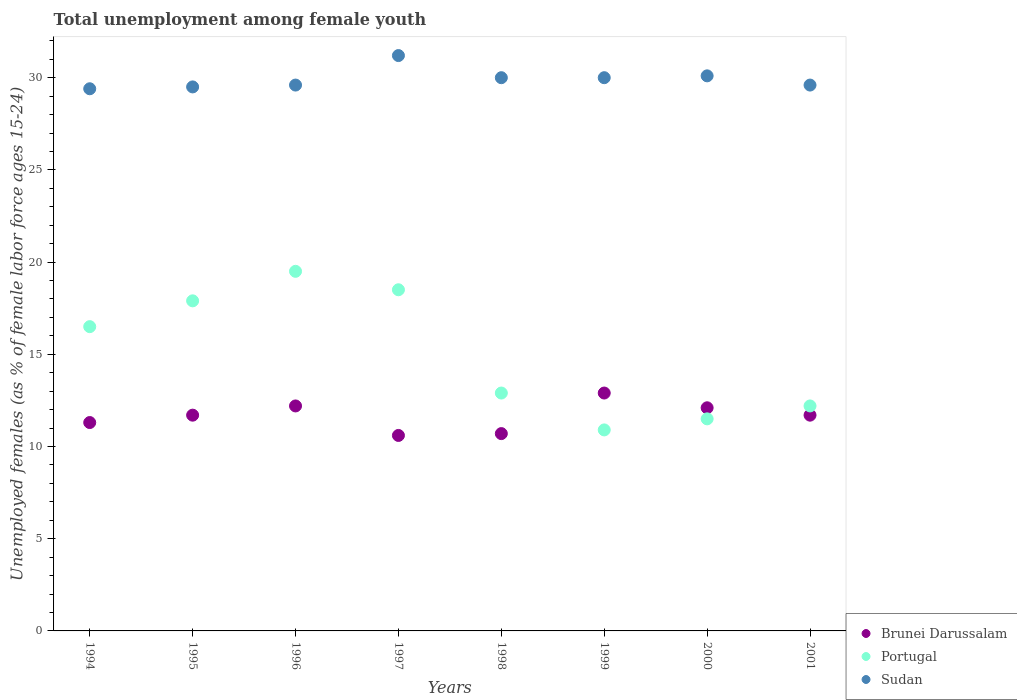Is the number of dotlines equal to the number of legend labels?
Offer a terse response. Yes. What is the percentage of unemployed females in in Sudan in 1999?
Provide a short and direct response. 30. Across all years, what is the maximum percentage of unemployed females in in Sudan?
Your answer should be compact. 31.2. Across all years, what is the minimum percentage of unemployed females in in Brunei Darussalam?
Your answer should be compact. 10.6. In which year was the percentage of unemployed females in in Sudan maximum?
Give a very brief answer. 1997. In which year was the percentage of unemployed females in in Portugal minimum?
Provide a succinct answer. 1999. What is the total percentage of unemployed females in in Portugal in the graph?
Give a very brief answer. 119.9. What is the difference between the percentage of unemployed females in in Sudan in 1996 and that in 1999?
Offer a very short reply. -0.4. What is the difference between the percentage of unemployed females in in Sudan in 1999 and the percentage of unemployed females in in Brunei Darussalam in 1996?
Offer a terse response. 17.8. What is the average percentage of unemployed females in in Portugal per year?
Offer a terse response. 14.99. In the year 1999, what is the difference between the percentage of unemployed females in in Sudan and percentage of unemployed females in in Portugal?
Your answer should be very brief. 19.1. In how many years, is the percentage of unemployed females in in Portugal greater than 24 %?
Provide a short and direct response. 0. What is the ratio of the percentage of unemployed females in in Portugal in 1997 to that in 2000?
Offer a terse response. 1.61. What is the difference between the highest and the second highest percentage of unemployed females in in Sudan?
Your answer should be very brief. 1.1. What is the difference between the highest and the lowest percentage of unemployed females in in Portugal?
Ensure brevity in your answer.  8.6. Is it the case that in every year, the sum of the percentage of unemployed females in in Sudan and percentage of unemployed females in in Brunei Darussalam  is greater than the percentage of unemployed females in in Portugal?
Give a very brief answer. Yes. How many years are there in the graph?
Give a very brief answer. 8. Are the values on the major ticks of Y-axis written in scientific E-notation?
Provide a succinct answer. No. Where does the legend appear in the graph?
Provide a short and direct response. Bottom right. What is the title of the graph?
Your answer should be compact. Total unemployment among female youth. Does "Thailand" appear as one of the legend labels in the graph?
Your response must be concise. No. What is the label or title of the X-axis?
Ensure brevity in your answer.  Years. What is the label or title of the Y-axis?
Offer a terse response. Unemployed females (as % of female labor force ages 15-24). What is the Unemployed females (as % of female labor force ages 15-24) of Brunei Darussalam in 1994?
Provide a succinct answer. 11.3. What is the Unemployed females (as % of female labor force ages 15-24) of Sudan in 1994?
Make the answer very short. 29.4. What is the Unemployed females (as % of female labor force ages 15-24) in Brunei Darussalam in 1995?
Give a very brief answer. 11.7. What is the Unemployed females (as % of female labor force ages 15-24) of Portugal in 1995?
Your answer should be very brief. 17.9. What is the Unemployed females (as % of female labor force ages 15-24) in Sudan in 1995?
Ensure brevity in your answer.  29.5. What is the Unemployed females (as % of female labor force ages 15-24) of Brunei Darussalam in 1996?
Keep it short and to the point. 12.2. What is the Unemployed females (as % of female labor force ages 15-24) of Portugal in 1996?
Give a very brief answer. 19.5. What is the Unemployed females (as % of female labor force ages 15-24) in Sudan in 1996?
Offer a terse response. 29.6. What is the Unemployed females (as % of female labor force ages 15-24) in Brunei Darussalam in 1997?
Your response must be concise. 10.6. What is the Unemployed females (as % of female labor force ages 15-24) in Sudan in 1997?
Keep it short and to the point. 31.2. What is the Unemployed females (as % of female labor force ages 15-24) in Brunei Darussalam in 1998?
Your answer should be compact. 10.7. What is the Unemployed females (as % of female labor force ages 15-24) in Portugal in 1998?
Make the answer very short. 12.9. What is the Unemployed females (as % of female labor force ages 15-24) of Sudan in 1998?
Make the answer very short. 30. What is the Unemployed females (as % of female labor force ages 15-24) in Brunei Darussalam in 1999?
Make the answer very short. 12.9. What is the Unemployed females (as % of female labor force ages 15-24) in Portugal in 1999?
Keep it short and to the point. 10.9. What is the Unemployed females (as % of female labor force ages 15-24) of Sudan in 1999?
Your answer should be very brief. 30. What is the Unemployed females (as % of female labor force ages 15-24) of Brunei Darussalam in 2000?
Your answer should be compact. 12.1. What is the Unemployed females (as % of female labor force ages 15-24) in Portugal in 2000?
Offer a terse response. 11.5. What is the Unemployed females (as % of female labor force ages 15-24) of Sudan in 2000?
Make the answer very short. 30.1. What is the Unemployed females (as % of female labor force ages 15-24) of Brunei Darussalam in 2001?
Ensure brevity in your answer.  11.7. What is the Unemployed females (as % of female labor force ages 15-24) of Portugal in 2001?
Make the answer very short. 12.2. What is the Unemployed females (as % of female labor force ages 15-24) in Sudan in 2001?
Provide a short and direct response. 29.6. Across all years, what is the maximum Unemployed females (as % of female labor force ages 15-24) in Brunei Darussalam?
Offer a terse response. 12.9. Across all years, what is the maximum Unemployed females (as % of female labor force ages 15-24) of Portugal?
Offer a very short reply. 19.5. Across all years, what is the maximum Unemployed females (as % of female labor force ages 15-24) of Sudan?
Your answer should be very brief. 31.2. Across all years, what is the minimum Unemployed females (as % of female labor force ages 15-24) in Brunei Darussalam?
Your answer should be compact. 10.6. Across all years, what is the minimum Unemployed females (as % of female labor force ages 15-24) in Portugal?
Ensure brevity in your answer.  10.9. Across all years, what is the minimum Unemployed females (as % of female labor force ages 15-24) of Sudan?
Your response must be concise. 29.4. What is the total Unemployed females (as % of female labor force ages 15-24) of Brunei Darussalam in the graph?
Offer a terse response. 93.2. What is the total Unemployed females (as % of female labor force ages 15-24) in Portugal in the graph?
Your answer should be very brief. 119.9. What is the total Unemployed females (as % of female labor force ages 15-24) of Sudan in the graph?
Ensure brevity in your answer.  239.4. What is the difference between the Unemployed females (as % of female labor force ages 15-24) of Sudan in 1994 and that in 1995?
Make the answer very short. -0.1. What is the difference between the Unemployed females (as % of female labor force ages 15-24) of Sudan in 1994 and that in 1996?
Provide a succinct answer. -0.2. What is the difference between the Unemployed females (as % of female labor force ages 15-24) of Sudan in 1994 and that in 1997?
Provide a succinct answer. -1.8. What is the difference between the Unemployed females (as % of female labor force ages 15-24) of Brunei Darussalam in 1994 and that in 1999?
Ensure brevity in your answer.  -1.6. What is the difference between the Unemployed females (as % of female labor force ages 15-24) of Brunei Darussalam in 1994 and that in 2000?
Ensure brevity in your answer.  -0.8. What is the difference between the Unemployed females (as % of female labor force ages 15-24) of Portugal in 1994 and that in 2000?
Offer a terse response. 5. What is the difference between the Unemployed females (as % of female labor force ages 15-24) of Sudan in 1994 and that in 2000?
Make the answer very short. -0.7. What is the difference between the Unemployed females (as % of female labor force ages 15-24) of Portugal in 1994 and that in 2001?
Offer a very short reply. 4.3. What is the difference between the Unemployed females (as % of female labor force ages 15-24) of Brunei Darussalam in 1995 and that in 1996?
Your answer should be very brief. -0.5. What is the difference between the Unemployed females (as % of female labor force ages 15-24) of Portugal in 1995 and that in 1997?
Give a very brief answer. -0.6. What is the difference between the Unemployed females (as % of female labor force ages 15-24) in Sudan in 1995 and that in 1997?
Your response must be concise. -1.7. What is the difference between the Unemployed females (as % of female labor force ages 15-24) in Brunei Darussalam in 1995 and that in 1998?
Offer a terse response. 1. What is the difference between the Unemployed females (as % of female labor force ages 15-24) of Portugal in 1995 and that in 1998?
Keep it short and to the point. 5. What is the difference between the Unemployed females (as % of female labor force ages 15-24) in Portugal in 1995 and that in 1999?
Provide a succinct answer. 7. What is the difference between the Unemployed females (as % of female labor force ages 15-24) of Portugal in 1995 and that in 2000?
Your answer should be compact. 6.4. What is the difference between the Unemployed females (as % of female labor force ages 15-24) in Sudan in 1995 and that in 2000?
Offer a terse response. -0.6. What is the difference between the Unemployed females (as % of female labor force ages 15-24) in Brunei Darussalam in 1995 and that in 2001?
Give a very brief answer. 0. What is the difference between the Unemployed females (as % of female labor force ages 15-24) of Portugal in 1995 and that in 2001?
Your answer should be compact. 5.7. What is the difference between the Unemployed females (as % of female labor force ages 15-24) of Sudan in 1995 and that in 2001?
Keep it short and to the point. -0.1. What is the difference between the Unemployed females (as % of female labor force ages 15-24) in Portugal in 1996 and that in 1997?
Offer a very short reply. 1. What is the difference between the Unemployed females (as % of female labor force ages 15-24) of Brunei Darussalam in 1996 and that in 1998?
Your response must be concise. 1.5. What is the difference between the Unemployed females (as % of female labor force ages 15-24) in Brunei Darussalam in 1996 and that in 1999?
Your answer should be compact. -0.7. What is the difference between the Unemployed females (as % of female labor force ages 15-24) of Portugal in 1996 and that in 1999?
Make the answer very short. 8.6. What is the difference between the Unemployed females (as % of female labor force ages 15-24) in Sudan in 1996 and that in 1999?
Give a very brief answer. -0.4. What is the difference between the Unemployed females (as % of female labor force ages 15-24) of Sudan in 1996 and that in 2000?
Your answer should be compact. -0.5. What is the difference between the Unemployed females (as % of female labor force ages 15-24) in Portugal in 1996 and that in 2001?
Provide a short and direct response. 7.3. What is the difference between the Unemployed females (as % of female labor force ages 15-24) in Sudan in 1997 and that in 1999?
Provide a short and direct response. 1.2. What is the difference between the Unemployed females (as % of female labor force ages 15-24) in Portugal in 1997 and that in 2000?
Your answer should be compact. 7. What is the difference between the Unemployed females (as % of female labor force ages 15-24) of Sudan in 1997 and that in 2001?
Your answer should be very brief. 1.6. What is the difference between the Unemployed females (as % of female labor force ages 15-24) of Sudan in 1998 and that in 2001?
Keep it short and to the point. 0.4. What is the difference between the Unemployed females (as % of female labor force ages 15-24) of Portugal in 1999 and that in 2000?
Offer a terse response. -0.6. What is the difference between the Unemployed females (as % of female labor force ages 15-24) of Portugal in 1999 and that in 2001?
Provide a succinct answer. -1.3. What is the difference between the Unemployed females (as % of female labor force ages 15-24) of Sudan in 2000 and that in 2001?
Make the answer very short. 0.5. What is the difference between the Unemployed females (as % of female labor force ages 15-24) of Brunei Darussalam in 1994 and the Unemployed females (as % of female labor force ages 15-24) of Portugal in 1995?
Provide a succinct answer. -6.6. What is the difference between the Unemployed females (as % of female labor force ages 15-24) in Brunei Darussalam in 1994 and the Unemployed females (as % of female labor force ages 15-24) in Sudan in 1995?
Provide a succinct answer. -18.2. What is the difference between the Unemployed females (as % of female labor force ages 15-24) in Brunei Darussalam in 1994 and the Unemployed females (as % of female labor force ages 15-24) in Sudan in 1996?
Offer a terse response. -18.3. What is the difference between the Unemployed females (as % of female labor force ages 15-24) of Brunei Darussalam in 1994 and the Unemployed females (as % of female labor force ages 15-24) of Sudan in 1997?
Your answer should be very brief. -19.9. What is the difference between the Unemployed females (as % of female labor force ages 15-24) of Portugal in 1994 and the Unemployed females (as % of female labor force ages 15-24) of Sudan in 1997?
Your response must be concise. -14.7. What is the difference between the Unemployed females (as % of female labor force ages 15-24) in Brunei Darussalam in 1994 and the Unemployed females (as % of female labor force ages 15-24) in Sudan in 1998?
Provide a succinct answer. -18.7. What is the difference between the Unemployed females (as % of female labor force ages 15-24) in Brunei Darussalam in 1994 and the Unemployed females (as % of female labor force ages 15-24) in Sudan in 1999?
Make the answer very short. -18.7. What is the difference between the Unemployed females (as % of female labor force ages 15-24) of Brunei Darussalam in 1994 and the Unemployed females (as % of female labor force ages 15-24) of Sudan in 2000?
Ensure brevity in your answer.  -18.8. What is the difference between the Unemployed females (as % of female labor force ages 15-24) of Portugal in 1994 and the Unemployed females (as % of female labor force ages 15-24) of Sudan in 2000?
Provide a succinct answer. -13.6. What is the difference between the Unemployed females (as % of female labor force ages 15-24) of Brunei Darussalam in 1994 and the Unemployed females (as % of female labor force ages 15-24) of Portugal in 2001?
Make the answer very short. -0.9. What is the difference between the Unemployed females (as % of female labor force ages 15-24) in Brunei Darussalam in 1994 and the Unemployed females (as % of female labor force ages 15-24) in Sudan in 2001?
Provide a short and direct response. -18.3. What is the difference between the Unemployed females (as % of female labor force ages 15-24) of Brunei Darussalam in 1995 and the Unemployed females (as % of female labor force ages 15-24) of Portugal in 1996?
Give a very brief answer. -7.8. What is the difference between the Unemployed females (as % of female labor force ages 15-24) in Brunei Darussalam in 1995 and the Unemployed females (as % of female labor force ages 15-24) in Sudan in 1996?
Give a very brief answer. -17.9. What is the difference between the Unemployed females (as % of female labor force ages 15-24) in Portugal in 1995 and the Unemployed females (as % of female labor force ages 15-24) in Sudan in 1996?
Your answer should be compact. -11.7. What is the difference between the Unemployed females (as % of female labor force ages 15-24) of Brunei Darussalam in 1995 and the Unemployed females (as % of female labor force ages 15-24) of Portugal in 1997?
Give a very brief answer. -6.8. What is the difference between the Unemployed females (as % of female labor force ages 15-24) in Brunei Darussalam in 1995 and the Unemployed females (as % of female labor force ages 15-24) in Sudan in 1997?
Keep it short and to the point. -19.5. What is the difference between the Unemployed females (as % of female labor force ages 15-24) of Brunei Darussalam in 1995 and the Unemployed females (as % of female labor force ages 15-24) of Portugal in 1998?
Give a very brief answer. -1.2. What is the difference between the Unemployed females (as % of female labor force ages 15-24) of Brunei Darussalam in 1995 and the Unemployed females (as % of female labor force ages 15-24) of Sudan in 1998?
Your answer should be compact. -18.3. What is the difference between the Unemployed females (as % of female labor force ages 15-24) in Portugal in 1995 and the Unemployed females (as % of female labor force ages 15-24) in Sudan in 1998?
Keep it short and to the point. -12.1. What is the difference between the Unemployed females (as % of female labor force ages 15-24) in Brunei Darussalam in 1995 and the Unemployed females (as % of female labor force ages 15-24) in Portugal in 1999?
Provide a succinct answer. 0.8. What is the difference between the Unemployed females (as % of female labor force ages 15-24) in Brunei Darussalam in 1995 and the Unemployed females (as % of female labor force ages 15-24) in Sudan in 1999?
Keep it short and to the point. -18.3. What is the difference between the Unemployed females (as % of female labor force ages 15-24) of Brunei Darussalam in 1995 and the Unemployed females (as % of female labor force ages 15-24) of Portugal in 2000?
Your answer should be compact. 0.2. What is the difference between the Unemployed females (as % of female labor force ages 15-24) of Brunei Darussalam in 1995 and the Unemployed females (as % of female labor force ages 15-24) of Sudan in 2000?
Your response must be concise. -18.4. What is the difference between the Unemployed females (as % of female labor force ages 15-24) in Brunei Darussalam in 1995 and the Unemployed females (as % of female labor force ages 15-24) in Sudan in 2001?
Provide a short and direct response. -17.9. What is the difference between the Unemployed females (as % of female labor force ages 15-24) in Brunei Darussalam in 1996 and the Unemployed females (as % of female labor force ages 15-24) in Sudan in 1998?
Ensure brevity in your answer.  -17.8. What is the difference between the Unemployed females (as % of female labor force ages 15-24) in Brunei Darussalam in 1996 and the Unemployed females (as % of female labor force ages 15-24) in Portugal in 1999?
Keep it short and to the point. 1.3. What is the difference between the Unemployed females (as % of female labor force ages 15-24) in Brunei Darussalam in 1996 and the Unemployed females (as % of female labor force ages 15-24) in Sudan in 1999?
Ensure brevity in your answer.  -17.8. What is the difference between the Unemployed females (as % of female labor force ages 15-24) of Portugal in 1996 and the Unemployed females (as % of female labor force ages 15-24) of Sudan in 1999?
Offer a terse response. -10.5. What is the difference between the Unemployed females (as % of female labor force ages 15-24) of Brunei Darussalam in 1996 and the Unemployed females (as % of female labor force ages 15-24) of Sudan in 2000?
Your answer should be very brief. -17.9. What is the difference between the Unemployed females (as % of female labor force ages 15-24) in Brunei Darussalam in 1996 and the Unemployed females (as % of female labor force ages 15-24) in Sudan in 2001?
Keep it short and to the point. -17.4. What is the difference between the Unemployed females (as % of female labor force ages 15-24) in Portugal in 1996 and the Unemployed females (as % of female labor force ages 15-24) in Sudan in 2001?
Your response must be concise. -10.1. What is the difference between the Unemployed females (as % of female labor force ages 15-24) of Brunei Darussalam in 1997 and the Unemployed females (as % of female labor force ages 15-24) of Sudan in 1998?
Make the answer very short. -19.4. What is the difference between the Unemployed females (as % of female labor force ages 15-24) of Portugal in 1997 and the Unemployed females (as % of female labor force ages 15-24) of Sudan in 1998?
Provide a succinct answer. -11.5. What is the difference between the Unemployed females (as % of female labor force ages 15-24) of Brunei Darussalam in 1997 and the Unemployed females (as % of female labor force ages 15-24) of Sudan in 1999?
Give a very brief answer. -19.4. What is the difference between the Unemployed females (as % of female labor force ages 15-24) of Portugal in 1997 and the Unemployed females (as % of female labor force ages 15-24) of Sudan in 1999?
Your response must be concise. -11.5. What is the difference between the Unemployed females (as % of female labor force ages 15-24) of Brunei Darussalam in 1997 and the Unemployed females (as % of female labor force ages 15-24) of Sudan in 2000?
Offer a terse response. -19.5. What is the difference between the Unemployed females (as % of female labor force ages 15-24) of Brunei Darussalam in 1997 and the Unemployed females (as % of female labor force ages 15-24) of Portugal in 2001?
Ensure brevity in your answer.  -1.6. What is the difference between the Unemployed females (as % of female labor force ages 15-24) in Portugal in 1997 and the Unemployed females (as % of female labor force ages 15-24) in Sudan in 2001?
Your response must be concise. -11.1. What is the difference between the Unemployed females (as % of female labor force ages 15-24) of Brunei Darussalam in 1998 and the Unemployed females (as % of female labor force ages 15-24) of Sudan in 1999?
Keep it short and to the point. -19.3. What is the difference between the Unemployed females (as % of female labor force ages 15-24) in Portugal in 1998 and the Unemployed females (as % of female labor force ages 15-24) in Sudan in 1999?
Ensure brevity in your answer.  -17.1. What is the difference between the Unemployed females (as % of female labor force ages 15-24) in Brunei Darussalam in 1998 and the Unemployed females (as % of female labor force ages 15-24) in Portugal in 2000?
Your response must be concise. -0.8. What is the difference between the Unemployed females (as % of female labor force ages 15-24) in Brunei Darussalam in 1998 and the Unemployed females (as % of female labor force ages 15-24) in Sudan in 2000?
Keep it short and to the point. -19.4. What is the difference between the Unemployed females (as % of female labor force ages 15-24) in Portugal in 1998 and the Unemployed females (as % of female labor force ages 15-24) in Sudan in 2000?
Keep it short and to the point. -17.2. What is the difference between the Unemployed females (as % of female labor force ages 15-24) of Brunei Darussalam in 1998 and the Unemployed females (as % of female labor force ages 15-24) of Sudan in 2001?
Keep it short and to the point. -18.9. What is the difference between the Unemployed females (as % of female labor force ages 15-24) of Portugal in 1998 and the Unemployed females (as % of female labor force ages 15-24) of Sudan in 2001?
Provide a short and direct response. -16.7. What is the difference between the Unemployed females (as % of female labor force ages 15-24) of Brunei Darussalam in 1999 and the Unemployed females (as % of female labor force ages 15-24) of Sudan in 2000?
Provide a succinct answer. -17.2. What is the difference between the Unemployed females (as % of female labor force ages 15-24) in Portugal in 1999 and the Unemployed females (as % of female labor force ages 15-24) in Sudan in 2000?
Offer a very short reply. -19.2. What is the difference between the Unemployed females (as % of female labor force ages 15-24) in Brunei Darussalam in 1999 and the Unemployed females (as % of female labor force ages 15-24) in Portugal in 2001?
Make the answer very short. 0.7. What is the difference between the Unemployed females (as % of female labor force ages 15-24) in Brunei Darussalam in 1999 and the Unemployed females (as % of female labor force ages 15-24) in Sudan in 2001?
Ensure brevity in your answer.  -16.7. What is the difference between the Unemployed females (as % of female labor force ages 15-24) of Portugal in 1999 and the Unemployed females (as % of female labor force ages 15-24) of Sudan in 2001?
Give a very brief answer. -18.7. What is the difference between the Unemployed females (as % of female labor force ages 15-24) of Brunei Darussalam in 2000 and the Unemployed females (as % of female labor force ages 15-24) of Portugal in 2001?
Provide a succinct answer. -0.1. What is the difference between the Unemployed females (as % of female labor force ages 15-24) of Brunei Darussalam in 2000 and the Unemployed females (as % of female labor force ages 15-24) of Sudan in 2001?
Offer a very short reply. -17.5. What is the difference between the Unemployed females (as % of female labor force ages 15-24) of Portugal in 2000 and the Unemployed females (as % of female labor force ages 15-24) of Sudan in 2001?
Ensure brevity in your answer.  -18.1. What is the average Unemployed females (as % of female labor force ages 15-24) of Brunei Darussalam per year?
Keep it short and to the point. 11.65. What is the average Unemployed females (as % of female labor force ages 15-24) in Portugal per year?
Provide a succinct answer. 14.99. What is the average Unemployed females (as % of female labor force ages 15-24) of Sudan per year?
Provide a short and direct response. 29.93. In the year 1994, what is the difference between the Unemployed females (as % of female labor force ages 15-24) in Brunei Darussalam and Unemployed females (as % of female labor force ages 15-24) in Portugal?
Keep it short and to the point. -5.2. In the year 1994, what is the difference between the Unemployed females (as % of female labor force ages 15-24) in Brunei Darussalam and Unemployed females (as % of female labor force ages 15-24) in Sudan?
Make the answer very short. -18.1. In the year 1994, what is the difference between the Unemployed females (as % of female labor force ages 15-24) of Portugal and Unemployed females (as % of female labor force ages 15-24) of Sudan?
Provide a short and direct response. -12.9. In the year 1995, what is the difference between the Unemployed females (as % of female labor force ages 15-24) of Brunei Darussalam and Unemployed females (as % of female labor force ages 15-24) of Sudan?
Your response must be concise. -17.8. In the year 1996, what is the difference between the Unemployed females (as % of female labor force ages 15-24) of Brunei Darussalam and Unemployed females (as % of female labor force ages 15-24) of Portugal?
Make the answer very short. -7.3. In the year 1996, what is the difference between the Unemployed females (as % of female labor force ages 15-24) in Brunei Darussalam and Unemployed females (as % of female labor force ages 15-24) in Sudan?
Offer a very short reply. -17.4. In the year 1997, what is the difference between the Unemployed females (as % of female labor force ages 15-24) of Brunei Darussalam and Unemployed females (as % of female labor force ages 15-24) of Portugal?
Offer a very short reply. -7.9. In the year 1997, what is the difference between the Unemployed females (as % of female labor force ages 15-24) in Brunei Darussalam and Unemployed females (as % of female labor force ages 15-24) in Sudan?
Provide a short and direct response. -20.6. In the year 1997, what is the difference between the Unemployed females (as % of female labor force ages 15-24) in Portugal and Unemployed females (as % of female labor force ages 15-24) in Sudan?
Your response must be concise. -12.7. In the year 1998, what is the difference between the Unemployed females (as % of female labor force ages 15-24) in Brunei Darussalam and Unemployed females (as % of female labor force ages 15-24) in Sudan?
Your response must be concise. -19.3. In the year 1998, what is the difference between the Unemployed females (as % of female labor force ages 15-24) of Portugal and Unemployed females (as % of female labor force ages 15-24) of Sudan?
Give a very brief answer. -17.1. In the year 1999, what is the difference between the Unemployed females (as % of female labor force ages 15-24) of Brunei Darussalam and Unemployed females (as % of female labor force ages 15-24) of Sudan?
Provide a short and direct response. -17.1. In the year 1999, what is the difference between the Unemployed females (as % of female labor force ages 15-24) in Portugal and Unemployed females (as % of female labor force ages 15-24) in Sudan?
Offer a very short reply. -19.1. In the year 2000, what is the difference between the Unemployed females (as % of female labor force ages 15-24) in Portugal and Unemployed females (as % of female labor force ages 15-24) in Sudan?
Your answer should be compact. -18.6. In the year 2001, what is the difference between the Unemployed females (as % of female labor force ages 15-24) of Brunei Darussalam and Unemployed females (as % of female labor force ages 15-24) of Portugal?
Provide a succinct answer. -0.5. In the year 2001, what is the difference between the Unemployed females (as % of female labor force ages 15-24) of Brunei Darussalam and Unemployed females (as % of female labor force ages 15-24) of Sudan?
Give a very brief answer. -17.9. In the year 2001, what is the difference between the Unemployed females (as % of female labor force ages 15-24) of Portugal and Unemployed females (as % of female labor force ages 15-24) of Sudan?
Ensure brevity in your answer.  -17.4. What is the ratio of the Unemployed females (as % of female labor force ages 15-24) of Brunei Darussalam in 1994 to that in 1995?
Provide a short and direct response. 0.97. What is the ratio of the Unemployed females (as % of female labor force ages 15-24) of Portugal in 1994 to that in 1995?
Keep it short and to the point. 0.92. What is the ratio of the Unemployed females (as % of female labor force ages 15-24) in Brunei Darussalam in 1994 to that in 1996?
Provide a short and direct response. 0.93. What is the ratio of the Unemployed females (as % of female labor force ages 15-24) in Portugal in 1994 to that in 1996?
Ensure brevity in your answer.  0.85. What is the ratio of the Unemployed females (as % of female labor force ages 15-24) of Sudan in 1994 to that in 1996?
Make the answer very short. 0.99. What is the ratio of the Unemployed females (as % of female labor force ages 15-24) of Brunei Darussalam in 1994 to that in 1997?
Provide a succinct answer. 1.07. What is the ratio of the Unemployed females (as % of female labor force ages 15-24) in Portugal in 1994 to that in 1997?
Give a very brief answer. 0.89. What is the ratio of the Unemployed females (as % of female labor force ages 15-24) in Sudan in 1994 to that in 1997?
Make the answer very short. 0.94. What is the ratio of the Unemployed females (as % of female labor force ages 15-24) in Brunei Darussalam in 1994 to that in 1998?
Your answer should be compact. 1.06. What is the ratio of the Unemployed females (as % of female labor force ages 15-24) of Portugal in 1994 to that in 1998?
Make the answer very short. 1.28. What is the ratio of the Unemployed females (as % of female labor force ages 15-24) of Brunei Darussalam in 1994 to that in 1999?
Offer a terse response. 0.88. What is the ratio of the Unemployed females (as % of female labor force ages 15-24) in Portugal in 1994 to that in 1999?
Your response must be concise. 1.51. What is the ratio of the Unemployed females (as % of female labor force ages 15-24) in Sudan in 1994 to that in 1999?
Make the answer very short. 0.98. What is the ratio of the Unemployed females (as % of female labor force ages 15-24) in Brunei Darussalam in 1994 to that in 2000?
Ensure brevity in your answer.  0.93. What is the ratio of the Unemployed females (as % of female labor force ages 15-24) of Portugal in 1994 to that in 2000?
Provide a short and direct response. 1.43. What is the ratio of the Unemployed females (as % of female labor force ages 15-24) in Sudan in 1994 to that in 2000?
Offer a very short reply. 0.98. What is the ratio of the Unemployed females (as % of female labor force ages 15-24) in Brunei Darussalam in 1994 to that in 2001?
Ensure brevity in your answer.  0.97. What is the ratio of the Unemployed females (as % of female labor force ages 15-24) of Portugal in 1994 to that in 2001?
Your answer should be compact. 1.35. What is the ratio of the Unemployed females (as % of female labor force ages 15-24) of Sudan in 1994 to that in 2001?
Your response must be concise. 0.99. What is the ratio of the Unemployed females (as % of female labor force ages 15-24) of Brunei Darussalam in 1995 to that in 1996?
Keep it short and to the point. 0.96. What is the ratio of the Unemployed females (as % of female labor force ages 15-24) in Portugal in 1995 to that in 1996?
Make the answer very short. 0.92. What is the ratio of the Unemployed females (as % of female labor force ages 15-24) of Sudan in 1995 to that in 1996?
Offer a very short reply. 1. What is the ratio of the Unemployed females (as % of female labor force ages 15-24) of Brunei Darussalam in 1995 to that in 1997?
Your response must be concise. 1.1. What is the ratio of the Unemployed females (as % of female labor force ages 15-24) of Portugal in 1995 to that in 1997?
Provide a succinct answer. 0.97. What is the ratio of the Unemployed females (as % of female labor force ages 15-24) in Sudan in 1995 to that in 1997?
Give a very brief answer. 0.95. What is the ratio of the Unemployed females (as % of female labor force ages 15-24) of Brunei Darussalam in 1995 to that in 1998?
Offer a terse response. 1.09. What is the ratio of the Unemployed females (as % of female labor force ages 15-24) of Portugal in 1995 to that in 1998?
Ensure brevity in your answer.  1.39. What is the ratio of the Unemployed females (as % of female labor force ages 15-24) in Sudan in 1995 to that in 1998?
Provide a short and direct response. 0.98. What is the ratio of the Unemployed females (as % of female labor force ages 15-24) of Brunei Darussalam in 1995 to that in 1999?
Your answer should be compact. 0.91. What is the ratio of the Unemployed females (as % of female labor force ages 15-24) in Portugal in 1995 to that in 1999?
Your response must be concise. 1.64. What is the ratio of the Unemployed females (as % of female labor force ages 15-24) of Sudan in 1995 to that in 1999?
Provide a succinct answer. 0.98. What is the ratio of the Unemployed females (as % of female labor force ages 15-24) in Brunei Darussalam in 1995 to that in 2000?
Your answer should be very brief. 0.97. What is the ratio of the Unemployed females (as % of female labor force ages 15-24) of Portugal in 1995 to that in 2000?
Keep it short and to the point. 1.56. What is the ratio of the Unemployed females (as % of female labor force ages 15-24) of Sudan in 1995 to that in 2000?
Offer a terse response. 0.98. What is the ratio of the Unemployed females (as % of female labor force ages 15-24) in Portugal in 1995 to that in 2001?
Provide a short and direct response. 1.47. What is the ratio of the Unemployed females (as % of female labor force ages 15-24) of Brunei Darussalam in 1996 to that in 1997?
Provide a succinct answer. 1.15. What is the ratio of the Unemployed females (as % of female labor force ages 15-24) in Portugal in 1996 to that in 1997?
Your response must be concise. 1.05. What is the ratio of the Unemployed females (as % of female labor force ages 15-24) of Sudan in 1996 to that in 1997?
Provide a succinct answer. 0.95. What is the ratio of the Unemployed females (as % of female labor force ages 15-24) of Brunei Darussalam in 1996 to that in 1998?
Keep it short and to the point. 1.14. What is the ratio of the Unemployed females (as % of female labor force ages 15-24) in Portugal in 1996 to that in 1998?
Your answer should be compact. 1.51. What is the ratio of the Unemployed females (as % of female labor force ages 15-24) of Sudan in 1996 to that in 1998?
Offer a very short reply. 0.99. What is the ratio of the Unemployed females (as % of female labor force ages 15-24) of Brunei Darussalam in 1996 to that in 1999?
Your response must be concise. 0.95. What is the ratio of the Unemployed females (as % of female labor force ages 15-24) of Portugal in 1996 to that in 1999?
Offer a terse response. 1.79. What is the ratio of the Unemployed females (as % of female labor force ages 15-24) of Sudan in 1996 to that in 1999?
Make the answer very short. 0.99. What is the ratio of the Unemployed females (as % of female labor force ages 15-24) of Brunei Darussalam in 1996 to that in 2000?
Give a very brief answer. 1.01. What is the ratio of the Unemployed females (as % of female labor force ages 15-24) of Portugal in 1996 to that in 2000?
Make the answer very short. 1.7. What is the ratio of the Unemployed females (as % of female labor force ages 15-24) of Sudan in 1996 to that in 2000?
Your answer should be very brief. 0.98. What is the ratio of the Unemployed females (as % of female labor force ages 15-24) in Brunei Darussalam in 1996 to that in 2001?
Your response must be concise. 1.04. What is the ratio of the Unemployed females (as % of female labor force ages 15-24) in Portugal in 1996 to that in 2001?
Ensure brevity in your answer.  1.6. What is the ratio of the Unemployed females (as % of female labor force ages 15-24) in Portugal in 1997 to that in 1998?
Your answer should be very brief. 1.43. What is the ratio of the Unemployed females (as % of female labor force ages 15-24) of Brunei Darussalam in 1997 to that in 1999?
Provide a short and direct response. 0.82. What is the ratio of the Unemployed females (as % of female labor force ages 15-24) in Portugal in 1997 to that in 1999?
Give a very brief answer. 1.7. What is the ratio of the Unemployed females (as % of female labor force ages 15-24) of Sudan in 1997 to that in 1999?
Your answer should be very brief. 1.04. What is the ratio of the Unemployed females (as % of female labor force ages 15-24) in Brunei Darussalam in 1997 to that in 2000?
Your answer should be compact. 0.88. What is the ratio of the Unemployed females (as % of female labor force ages 15-24) of Portugal in 1997 to that in 2000?
Make the answer very short. 1.61. What is the ratio of the Unemployed females (as % of female labor force ages 15-24) of Sudan in 1997 to that in 2000?
Your answer should be very brief. 1.04. What is the ratio of the Unemployed females (as % of female labor force ages 15-24) of Brunei Darussalam in 1997 to that in 2001?
Provide a succinct answer. 0.91. What is the ratio of the Unemployed females (as % of female labor force ages 15-24) of Portugal in 1997 to that in 2001?
Make the answer very short. 1.52. What is the ratio of the Unemployed females (as % of female labor force ages 15-24) in Sudan in 1997 to that in 2001?
Offer a very short reply. 1.05. What is the ratio of the Unemployed females (as % of female labor force ages 15-24) in Brunei Darussalam in 1998 to that in 1999?
Make the answer very short. 0.83. What is the ratio of the Unemployed females (as % of female labor force ages 15-24) of Portugal in 1998 to that in 1999?
Offer a very short reply. 1.18. What is the ratio of the Unemployed females (as % of female labor force ages 15-24) in Sudan in 1998 to that in 1999?
Offer a very short reply. 1. What is the ratio of the Unemployed females (as % of female labor force ages 15-24) of Brunei Darussalam in 1998 to that in 2000?
Provide a succinct answer. 0.88. What is the ratio of the Unemployed females (as % of female labor force ages 15-24) of Portugal in 1998 to that in 2000?
Provide a succinct answer. 1.12. What is the ratio of the Unemployed females (as % of female labor force ages 15-24) in Sudan in 1998 to that in 2000?
Keep it short and to the point. 1. What is the ratio of the Unemployed females (as % of female labor force ages 15-24) in Brunei Darussalam in 1998 to that in 2001?
Provide a succinct answer. 0.91. What is the ratio of the Unemployed females (as % of female labor force ages 15-24) in Portugal in 1998 to that in 2001?
Offer a terse response. 1.06. What is the ratio of the Unemployed females (as % of female labor force ages 15-24) in Sudan in 1998 to that in 2001?
Give a very brief answer. 1.01. What is the ratio of the Unemployed females (as % of female labor force ages 15-24) of Brunei Darussalam in 1999 to that in 2000?
Your answer should be very brief. 1.07. What is the ratio of the Unemployed females (as % of female labor force ages 15-24) in Portugal in 1999 to that in 2000?
Give a very brief answer. 0.95. What is the ratio of the Unemployed females (as % of female labor force ages 15-24) of Brunei Darussalam in 1999 to that in 2001?
Provide a succinct answer. 1.1. What is the ratio of the Unemployed females (as % of female labor force ages 15-24) in Portugal in 1999 to that in 2001?
Give a very brief answer. 0.89. What is the ratio of the Unemployed females (as % of female labor force ages 15-24) of Sudan in 1999 to that in 2001?
Offer a terse response. 1.01. What is the ratio of the Unemployed females (as % of female labor force ages 15-24) of Brunei Darussalam in 2000 to that in 2001?
Keep it short and to the point. 1.03. What is the ratio of the Unemployed females (as % of female labor force ages 15-24) of Portugal in 2000 to that in 2001?
Offer a very short reply. 0.94. What is the ratio of the Unemployed females (as % of female labor force ages 15-24) of Sudan in 2000 to that in 2001?
Make the answer very short. 1.02. What is the difference between the highest and the second highest Unemployed females (as % of female labor force ages 15-24) in Brunei Darussalam?
Offer a terse response. 0.7. What is the difference between the highest and the second highest Unemployed females (as % of female labor force ages 15-24) in Portugal?
Make the answer very short. 1. What is the difference between the highest and the lowest Unemployed females (as % of female labor force ages 15-24) of Brunei Darussalam?
Offer a very short reply. 2.3. What is the difference between the highest and the lowest Unemployed females (as % of female labor force ages 15-24) in Portugal?
Your response must be concise. 8.6. What is the difference between the highest and the lowest Unemployed females (as % of female labor force ages 15-24) in Sudan?
Make the answer very short. 1.8. 